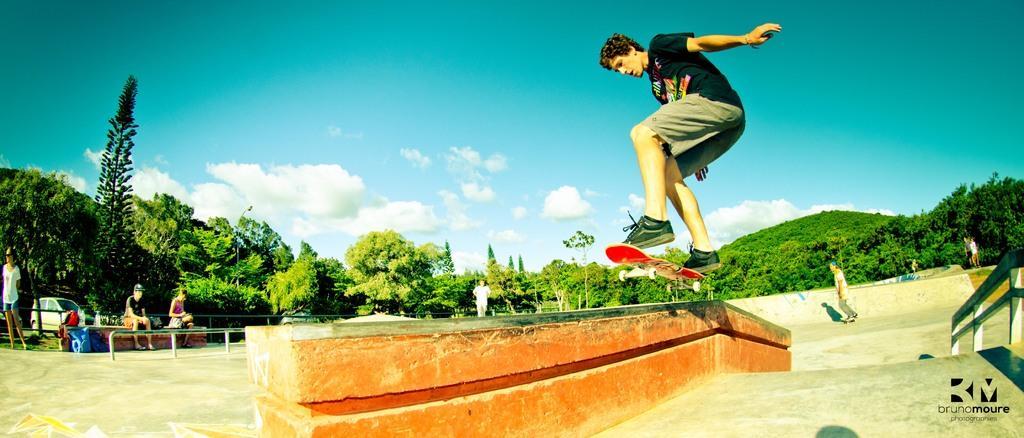How would you summarize this image in a sentence or two? In this image we can see a person on a skateboard. In the background of the image there are trees. There are people, car. At the top of the image there is sky and clouds. At the bottom of the image there is floor. 